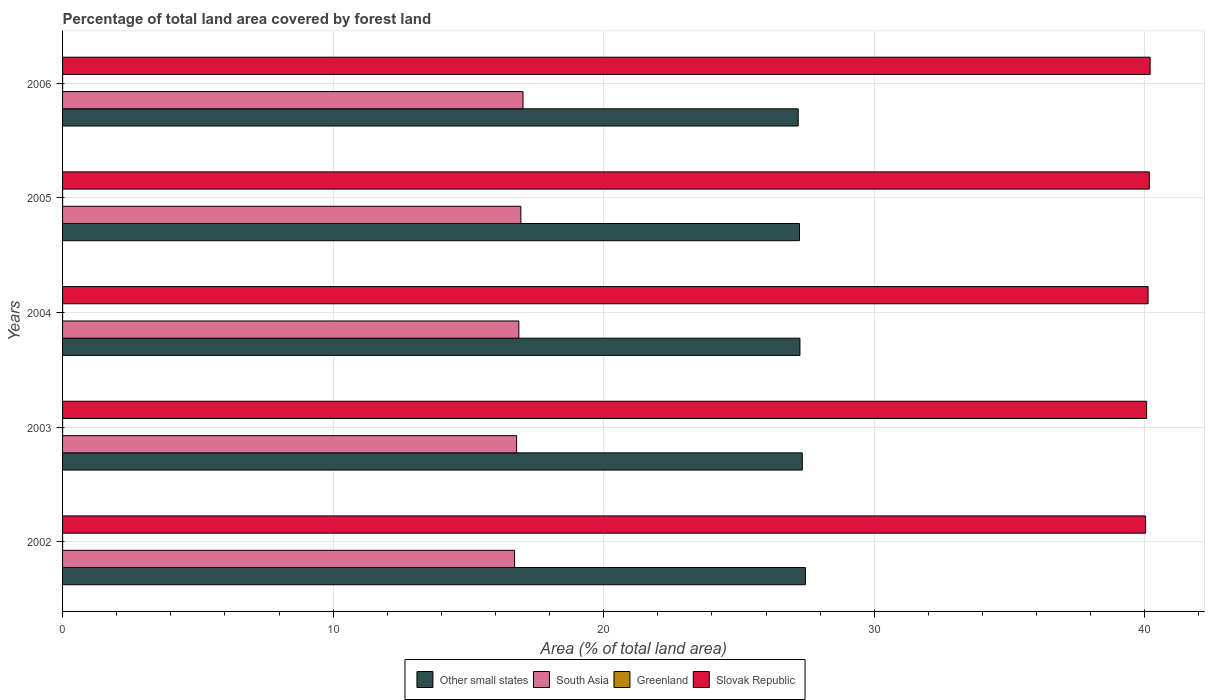How many different coloured bars are there?
Keep it short and to the point. 4. How many groups of bars are there?
Your answer should be compact. 5. Are the number of bars on each tick of the Y-axis equal?
Ensure brevity in your answer.  Yes. How many bars are there on the 1st tick from the top?
Offer a terse response. 4. How many bars are there on the 1st tick from the bottom?
Your answer should be compact. 4. What is the percentage of forest land in Slovak Republic in 2005?
Make the answer very short. 40.17. Across all years, what is the maximum percentage of forest land in South Asia?
Provide a succinct answer. 17.02. Across all years, what is the minimum percentage of forest land in Slovak Republic?
Keep it short and to the point. 40.03. What is the total percentage of forest land in South Asia in the graph?
Your response must be concise. 84.31. What is the difference between the percentage of forest land in Other small states in 2004 and that in 2006?
Your answer should be very brief. 0.06. What is the difference between the percentage of forest land in South Asia in 2004 and the percentage of forest land in Slovak Republic in 2002?
Offer a very short reply. -23.17. What is the average percentage of forest land in Greenland per year?
Your answer should be very brief. 0. In the year 2006, what is the difference between the percentage of forest land in Slovak Republic and percentage of forest land in Other small states?
Make the answer very short. 13.01. In how many years, is the percentage of forest land in South Asia greater than 38 %?
Ensure brevity in your answer.  0. What is the ratio of the percentage of forest land in Slovak Republic in 2002 to that in 2003?
Your response must be concise. 1. Is the percentage of forest land in Other small states in 2005 less than that in 2006?
Your response must be concise. No. Is the difference between the percentage of forest land in Slovak Republic in 2004 and 2006 greater than the difference between the percentage of forest land in Other small states in 2004 and 2006?
Provide a short and direct response. No. What is the difference between the highest and the second highest percentage of forest land in Other small states?
Offer a terse response. 0.11. What is the difference between the highest and the lowest percentage of forest land in Other small states?
Provide a short and direct response. 0.27. In how many years, is the percentage of forest land in Other small states greater than the average percentage of forest land in Other small states taken over all years?
Keep it short and to the point. 2. Is the sum of the percentage of forest land in South Asia in 2002 and 2006 greater than the maximum percentage of forest land in Other small states across all years?
Provide a short and direct response. Yes. What does the 2nd bar from the top in 2002 represents?
Provide a succinct answer. Greenland. What does the 4th bar from the bottom in 2004 represents?
Offer a terse response. Slovak Republic. Are all the bars in the graph horizontal?
Ensure brevity in your answer.  Yes. What is the difference between two consecutive major ticks on the X-axis?
Your answer should be compact. 10. Are the values on the major ticks of X-axis written in scientific E-notation?
Keep it short and to the point. No. Where does the legend appear in the graph?
Offer a terse response. Bottom center. What is the title of the graph?
Give a very brief answer. Percentage of total land area covered by forest land. What is the label or title of the X-axis?
Your answer should be very brief. Area (% of total land area). What is the label or title of the Y-axis?
Your response must be concise. Years. What is the Area (% of total land area) of Other small states in 2002?
Give a very brief answer. 27.45. What is the Area (% of total land area) of South Asia in 2002?
Offer a terse response. 16.71. What is the Area (% of total land area) in Greenland in 2002?
Offer a terse response. 0. What is the Area (% of total land area) in Slovak Republic in 2002?
Keep it short and to the point. 40.03. What is the Area (% of total land area) of Other small states in 2003?
Offer a terse response. 27.34. What is the Area (% of total land area) in South Asia in 2003?
Make the answer very short. 16.78. What is the Area (% of total land area) in Greenland in 2003?
Keep it short and to the point. 0. What is the Area (% of total land area) of Slovak Republic in 2003?
Your answer should be very brief. 40.07. What is the Area (% of total land area) in Other small states in 2004?
Give a very brief answer. 27.25. What is the Area (% of total land area) of South Asia in 2004?
Provide a short and direct response. 16.86. What is the Area (% of total land area) in Greenland in 2004?
Provide a succinct answer. 0. What is the Area (% of total land area) in Slovak Republic in 2004?
Provide a succinct answer. 40.12. What is the Area (% of total land area) in Other small states in 2005?
Give a very brief answer. 27.24. What is the Area (% of total land area) in South Asia in 2005?
Your answer should be very brief. 16.94. What is the Area (% of total land area) in Greenland in 2005?
Your answer should be very brief. 0. What is the Area (% of total land area) in Slovak Republic in 2005?
Offer a very short reply. 40.17. What is the Area (% of total land area) of Other small states in 2006?
Ensure brevity in your answer.  27.19. What is the Area (% of total land area) in South Asia in 2006?
Your answer should be very brief. 17.02. What is the Area (% of total land area) of Greenland in 2006?
Your answer should be very brief. 0. What is the Area (% of total land area) of Slovak Republic in 2006?
Offer a very short reply. 40.2. Across all years, what is the maximum Area (% of total land area) of Other small states?
Your response must be concise. 27.45. Across all years, what is the maximum Area (% of total land area) of South Asia?
Keep it short and to the point. 17.02. Across all years, what is the maximum Area (% of total land area) of Greenland?
Keep it short and to the point. 0. Across all years, what is the maximum Area (% of total land area) in Slovak Republic?
Offer a terse response. 40.2. Across all years, what is the minimum Area (% of total land area) in Other small states?
Make the answer very short. 27.19. Across all years, what is the minimum Area (% of total land area) of South Asia?
Your answer should be very brief. 16.71. Across all years, what is the minimum Area (% of total land area) of Greenland?
Your answer should be compact. 0. Across all years, what is the minimum Area (% of total land area) of Slovak Republic?
Provide a short and direct response. 40.03. What is the total Area (% of total land area) in Other small states in the graph?
Ensure brevity in your answer.  136.47. What is the total Area (% of total land area) in South Asia in the graph?
Ensure brevity in your answer.  84.31. What is the total Area (% of total land area) in Greenland in the graph?
Provide a short and direct response. 0. What is the total Area (% of total land area) of Slovak Republic in the graph?
Ensure brevity in your answer.  200.58. What is the difference between the Area (% of total land area) of Other small states in 2002 and that in 2003?
Offer a very short reply. 0.11. What is the difference between the Area (% of total land area) in South Asia in 2002 and that in 2003?
Keep it short and to the point. -0.08. What is the difference between the Area (% of total land area) of Greenland in 2002 and that in 2003?
Offer a very short reply. 0. What is the difference between the Area (% of total land area) of Slovak Republic in 2002 and that in 2003?
Make the answer very short. -0.04. What is the difference between the Area (% of total land area) of Other small states in 2002 and that in 2004?
Provide a short and direct response. 0.2. What is the difference between the Area (% of total land area) of South Asia in 2002 and that in 2004?
Provide a succinct answer. -0.16. What is the difference between the Area (% of total land area) of Greenland in 2002 and that in 2004?
Offer a very short reply. 0. What is the difference between the Area (% of total land area) of Slovak Republic in 2002 and that in 2004?
Ensure brevity in your answer.  -0.09. What is the difference between the Area (% of total land area) in Other small states in 2002 and that in 2005?
Keep it short and to the point. 0.22. What is the difference between the Area (% of total land area) of South Asia in 2002 and that in 2005?
Offer a very short reply. -0.23. What is the difference between the Area (% of total land area) in Slovak Republic in 2002 and that in 2005?
Your response must be concise. -0.14. What is the difference between the Area (% of total land area) in Other small states in 2002 and that in 2006?
Offer a very short reply. 0.27. What is the difference between the Area (% of total land area) in South Asia in 2002 and that in 2006?
Give a very brief answer. -0.31. What is the difference between the Area (% of total land area) in Greenland in 2002 and that in 2006?
Your response must be concise. 0. What is the difference between the Area (% of total land area) of Slovak Republic in 2002 and that in 2006?
Keep it short and to the point. -0.17. What is the difference between the Area (% of total land area) of Other small states in 2003 and that in 2004?
Your answer should be compact. 0.09. What is the difference between the Area (% of total land area) of South Asia in 2003 and that in 2004?
Offer a terse response. -0.08. What is the difference between the Area (% of total land area) in Slovak Republic in 2003 and that in 2004?
Provide a short and direct response. -0.05. What is the difference between the Area (% of total land area) of Other small states in 2003 and that in 2005?
Offer a very short reply. 0.11. What is the difference between the Area (% of total land area) in South Asia in 2003 and that in 2005?
Offer a very short reply. -0.16. What is the difference between the Area (% of total land area) in Greenland in 2003 and that in 2005?
Make the answer very short. 0. What is the difference between the Area (% of total land area) of Slovak Republic in 2003 and that in 2005?
Your answer should be very brief. -0.1. What is the difference between the Area (% of total land area) in Other small states in 2003 and that in 2006?
Ensure brevity in your answer.  0.15. What is the difference between the Area (% of total land area) of South Asia in 2003 and that in 2006?
Keep it short and to the point. -0.24. What is the difference between the Area (% of total land area) in Greenland in 2003 and that in 2006?
Your answer should be very brief. 0. What is the difference between the Area (% of total land area) of Slovak Republic in 2003 and that in 2006?
Your response must be concise. -0.13. What is the difference between the Area (% of total land area) of Other small states in 2004 and that in 2005?
Your answer should be compact. 0.02. What is the difference between the Area (% of total land area) in South Asia in 2004 and that in 2005?
Keep it short and to the point. -0.08. What is the difference between the Area (% of total land area) in Greenland in 2004 and that in 2005?
Keep it short and to the point. 0. What is the difference between the Area (% of total land area) of Slovak Republic in 2004 and that in 2005?
Keep it short and to the point. -0.05. What is the difference between the Area (% of total land area) in Other small states in 2004 and that in 2006?
Give a very brief answer. 0.06. What is the difference between the Area (% of total land area) of South Asia in 2004 and that in 2006?
Your response must be concise. -0.15. What is the difference between the Area (% of total land area) of Greenland in 2004 and that in 2006?
Your response must be concise. 0. What is the difference between the Area (% of total land area) of Slovak Republic in 2004 and that in 2006?
Ensure brevity in your answer.  -0.07. What is the difference between the Area (% of total land area) of Other small states in 2005 and that in 2006?
Provide a succinct answer. 0.05. What is the difference between the Area (% of total land area) in South Asia in 2005 and that in 2006?
Give a very brief answer. -0.08. What is the difference between the Area (% of total land area) in Greenland in 2005 and that in 2006?
Give a very brief answer. 0. What is the difference between the Area (% of total land area) in Slovak Republic in 2005 and that in 2006?
Ensure brevity in your answer.  -0.03. What is the difference between the Area (% of total land area) in Other small states in 2002 and the Area (% of total land area) in South Asia in 2003?
Offer a very short reply. 10.67. What is the difference between the Area (% of total land area) of Other small states in 2002 and the Area (% of total land area) of Greenland in 2003?
Keep it short and to the point. 27.45. What is the difference between the Area (% of total land area) of Other small states in 2002 and the Area (% of total land area) of Slovak Republic in 2003?
Offer a terse response. -12.61. What is the difference between the Area (% of total land area) in South Asia in 2002 and the Area (% of total land area) in Greenland in 2003?
Your answer should be very brief. 16.71. What is the difference between the Area (% of total land area) in South Asia in 2002 and the Area (% of total land area) in Slovak Republic in 2003?
Ensure brevity in your answer.  -23.36. What is the difference between the Area (% of total land area) of Greenland in 2002 and the Area (% of total land area) of Slovak Republic in 2003?
Your answer should be very brief. -40.07. What is the difference between the Area (% of total land area) in Other small states in 2002 and the Area (% of total land area) in South Asia in 2004?
Offer a very short reply. 10.59. What is the difference between the Area (% of total land area) of Other small states in 2002 and the Area (% of total land area) of Greenland in 2004?
Ensure brevity in your answer.  27.45. What is the difference between the Area (% of total land area) of Other small states in 2002 and the Area (% of total land area) of Slovak Republic in 2004?
Keep it short and to the point. -12.67. What is the difference between the Area (% of total land area) in South Asia in 2002 and the Area (% of total land area) in Greenland in 2004?
Ensure brevity in your answer.  16.71. What is the difference between the Area (% of total land area) in South Asia in 2002 and the Area (% of total land area) in Slovak Republic in 2004?
Make the answer very short. -23.41. What is the difference between the Area (% of total land area) in Greenland in 2002 and the Area (% of total land area) in Slovak Republic in 2004?
Keep it short and to the point. -40.12. What is the difference between the Area (% of total land area) in Other small states in 2002 and the Area (% of total land area) in South Asia in 2005?
Provide a short and direct response. 10.52. What is the difference between the Area (% of total land area) in Other small states in 2002 and the Area (% of total land area) in Greenland in 2005?
Give a very brief answer. 27.45. What is the difference between the Area (% of total land area) of Other small states in 2002 and the Area (% of total land area) of Slovak Republic in 2005?
Keep it short and to the point. -12.71. What is the difference between the Area (% of total land area) in South Asia in 2002 and the Area (% of total land area) in Greenland in 2005?
Ensure brevity in your answer.  16.71. What is the difference between the Area (% of total land area) in South Asia in 2002 and the Area (% of total land area) in Slovak Republic in 2005?
Make the answer very short. -23.46. What is the difference between the Area (% of total land area) of Greenland in 2002 and the Area (% of total land area) of Slovak Republic in 2005?
Provide a succinct answer. -40.17. What is the difference between the Area (% of total land area) of Other small states in 2002 and the Area (% of total land area) of South Asia in 2006?
Your response must be concise. 10.44. What is the difference between the Area (% of total land area) in Other small states in 2002 and the Area (% of total land area) in Greenland in 2006?
Your answer should be compact. 27.45. What is the difference between the Area (% of total land area) of Other small states in 2002 and the Area (% of total land area) of Slovak Republic in 2006?
Your answer should be compact. -12.74. What is the difference between the Area (% of total land area) in South Asia in 2002 and the Area (% of total land area) in Greenland in 2006?
Provide a short and direct response. 16.71. What is the difference between the Area (% of total land area) in South Asia in 2002 and the Area (% of total land area) in Slovak Republic in 2006?
Provide a short and direct response. -23.49. What is the difference between the Area (% of total land area) in Greenland in 2002 and the Area (% of total land area) in Slovak Republic in 2006?
Your answer should be very brief. -40.19. What is the difference between the Area (% of total land area) of Other small states in 2003 and the Area (% of total land area) of South Asia in 2004?
Give a very brief answer. 10.48. What is the difference between the Area (% of total land area) in Other small states in 2003 and the Area (% of total land area) in Greenland in 2004?
Ensure brevity in your answer.  27.34. What is the difference between the Area (% of total land area) in Other small states in 2003 and the Area (% of total land area) in Slovak Republic in 2004?
Your response must be concise. -12.78. What is the difference between the Area (% of total land area) of South Asia in 2003 and the Area (% of total land area) of Greenland in 2004?
Ensure brevity in your answer.  16.78. What is the difference between the Area (% of total land area) in South Asia in 2003 and the Area (% of total land area) in Slovak Republic in 2004?
Offer a terse response. -23.34. What is the difference between the Area (% of total land area) in Greenland in 2003 and the Area (% of total land area) in Slovak Republic in 2004?
Your answer should be compact. -40.12. What is the difference between the Area (% of total land area) of Other small states in 2003 and the Area (% of total land area) of South Asia in 2005?
Offer a terse response. 10.4. What is the difference between the Area (% of total land area) of Other small states in 2003 and the Area (% of total land area) of Greenland in 2005?
Provide a short and direct response. 27.34. What is the difference between the Area (% of total land area) of Other small states in 2003 and the Area (% of total land area) of Slovak Republic in 2005?
Provide a short and direct response. -12.82. What is the difference between the Area (% of total land area) of South Asia in 2003 and the Area (% of total land area) of Greenland in 2005?
Offer a terse response. 16.78. What is the difference between the Area (% of total land area) in South Asia in 2003 and the Area (% of total land area) in Slovak Republic in 2005?
Provide a short and direct response. -23.38. What is the difference between the Area (% of total land area) in Greenland in 2003 and the Area (% of total land area) in Slovak Republic in 2005?
Provide a short and direct response. -40.17. What is the difference between the Area (% of total land area) of Other small states in 2003 and the Area (% of total land area) of South Asia in 2006?
Give a very brief answer. 10.32. What is the difference between the Area (% of total land area) in Other small states in 2003 and the Area (% of total land area) in Greenland in 2006?
Your answer should be very brief. 27.34. What is the difference between the Area (% of total land area) in Other small states in 2003 and the Area (% of total land area) in Slovak Republic in 2006?
Offer a very short reply. -12.85. What is the difference between the Area (% of total land area) of South Asia in 2003 and the Area (% of total land area) of Greenland in 2006?
Ensure brevity in your answer.  16.78. What is the difference between the Area (% of total land area) of South Asia in 2003 and the Area (% of total land area) of Slovak Republic in 2006?
Ensure brevity in your answer.  -23.41. What is the difference between the Area (% of total land area) in Greenland in 2003 and the Area (% of total land area) in Slovak Republic in 2006?
Ensure brevity in your answer.  -40.19. What is the difference between the Area (% of total land area) of Other small states in 2004 and the Area (% of total land area) of South Asia in 2005?
Ensure brevity in your answer.  10.31. What is the difference between the Area (% of total land area) in Other small states in 2004 and the Area (% of total land area) in Greenland in 2005?
Give a very brief answer. 27.25. What is the difference between the Area (% of total land area) in Other small states in 2004 and the Area (% of total land area) in Slovak Republic in 2005?
Keep it short and to the point. -12.91. What is the difference between the Area (% of total land area) of South Asia in 2004 and the Area (% of total land area) of Greenland in 2005?
Your answer should be compact. 16.86. What is the difference between the Area (% of total land area) in South Asia in 2004 and the Area (% of total land area) in Slovak Republic in 2005?
Your answer should be compact. -23.3. What is the difference between the Area (% of total land area) in Greenland in 2004 and the Area (% of total land area) in Slovak Republic in 2005?
Ensure brevity in your answer.  -40.17. What is the difference between the Area (% of total land area) in Other small states in 2004 and the Area (% of total land area) in South Asia in 2006?
Keep it short and to the point. 10.23. What is the difference between the Area (% of total land area) of Other small states in 2004 and the Area (% of total land area) of Greenland in 2006?
Your response must be concise. 27.25. What is the difference between the Area (% of total land area) of Other small states in 2004 and the Area (% of total land area) of Slovak Republic in 2006?
Make the answer very short. -12.94. What is the difference between the Area (% of total land area) of South Asia in 2004 and the Area (% of total land area) of Greenland in 2006?
Your answer should be compact. 16.86. What is the difference between the Area (% of total land area) in South Asia in 2004 and the Area (% of total land area) in Slovak Republic in 2006?
Ensure brevity in your answer.  -23.33. What is the difference between the Area (% of total land area) of Greenland in 2004 and the Area (% of total land area) of Slovak Republic in 2006?
Provide a short and direct response. -40.19. What is the difference between the Area (% of total land area) in Other small states in 2005 and the Area (% of total land area) in South Asia in 2006?
Offer a terse response. 10.22. What is the difference between the Area (% of total land area) in Other small states in 2005 and the Area (% of total land area) in Greenland in 2006?
Provide a short and direct response. 27.23. What is the difference between the Area (% of total land area) in Other small states in 2005 and the Area (% of total land area) in Slovak Republic in 2006?
Your answer should be compact. -12.96. What is the difference between the Area (% of total land area) of South Asia in 2005 and the Area (% of total land area) of Greenland in 2006?
Your answer should be very brief. 16.94. What is the difference between the Area (% of total land area) of South Asia in 2005 and the Area (% of total land area) of Slovak Republic in 2006?
Your answer should be very brief. -23.26. What is the difference between the Area (% of total land area) of Greenland in 2005 and the Area (% of total land area) of Slovak Republic in 2006?
Ensure brevity in your answer.  -40.19. What is the average Area (% of total land area) of Other small states per year?
Give a very brief answer. 27.29. What is the average Area (% of total land area) of South Asia per year?
Provide a succinct answer. 16.86. What is the average Area (% of total land area) of Slovak Republic per year?
Your response must be concise. 40.12. In the year 2002, what is the difference between the Area (% of total land area) in Other small states and Area (% of total land area) in South Asia?
Keep it short and to the point. 10.75. In the year 2002, what is the difference between the Area (% of total land area) in Other small states and Area (% of total land area) in Greenland?
Provide a short and direct response. 27.45. In the year 2002, what is the difference between the Area (% of total land area) of Other small states and Area (% of total land area) of Slovak Republic?
Provide a succinct answer. -12.57. In the year 2002, what is the difference between the Area (% of total land area) in South Asia and Area (% of total land area) in Greenland?
Your response must be concise. 16.71. In the year 2002, what is the difference between the Area (% of total land area) of South Asia and Area (% of total land area) of Slovak Republic?
Your answer should be compact. -23.32. In the year 2002, what is the difference between the Area (% of total land area) of Greenland and Area (% of total land area) of Slovak Republic?
Keep it short and to the point. -40.03. In the year 2003, what is the difference between the Area (% of total land area) in Other small states and Area (% of total land area) in South Asia?
Keep it short and to the point. 10.56. In the year 2003, what is the difference between the Area (% of total land area) of Other small states and Area (% of total land area) of Greenland?
Keep it short and to the point. 27.34. In the year 2003, what is the difference between the Area (% of total land area) of Other small states and Area (% of total land area) of Slovak Republic?
Give a very brief answer. -12.72. In the year 2003, what is the difference between the Area (% of total land area) of South Asia and Area (% of total land area) of Greenland?
Your answer should be compact. 16.78. In the year 2003, what is the difference between the Area (% of total land area) of South Asia and Area (% of total land area) of Slovak Republic?
Offer a terse response. -23.28. In the year 2003, what is the difference between the Area (% of total land area) of Greenland and Area (% of total land area) of Slovak Republic?
Make the answer very short. -40.07. In the year 2004, what is the difference between the Area (% of total land area) of Other small states and Area (% of total land area) of South Asia?
Ensure brevity in your answer.  10.39. In the year 2004, what is the difference between the Area (% of total land area) in Other small states and Area (% of total land area) in Greenland?
Offer a very short reply. 27.25. In the year 2004, what is the difference between the Area (% of total land area) of Other small states and Area (% of total land area) of Slovak Republic?
Provide a short and direct response. -12.87. In the year 2004, what is the difference between the Area (% of total land area) of South Asia and Area (% of total land area) of Greenland?
Your answer should be compact. 16.86. In the year 2004, what is the difference between the Area (% of total land area) of South Asia and Area (% of total land area) of Slovak Republic?
Offer a terse response. -23.26. In the year 2004, what is the difference between the Area (% of total land area) in Greenland and Area (% of total land area) in Slovak Republic?
Your answer should be very brief. -40.12. In the year 2005, what is the difference between the Area (% of total land area) of Other small states and Area (% of total land area) of South Asia?
Provide a succinct answer. 10.3. In the year 2005, what is the difference between the Area (% of total land area) of Other small states and Area (% of total land area) of Greenland?
Offer a very short reply. 27.23. In the year 2005, what is the difference between the Area (% of total land area) in Other small states and Area (% of total land area) in Slovak Republic?
Make the answer very short. -12.93. In the year 2005, what is the difference between the Area (% of total land area) in South Asia and Area (% of total land area) in Greenland?
Ensure brevity in your answer.  16.94. In the year 2005, what is the difference between the Area (% of total land area) of South Asia and Area (% of total land area) of Slovak Republic?
Your answer should be very brief. -23.23. In the year 2005, what is the difference between the Area (% of total land area) of Greenland and Area (% of total land area) of Slovak Republic?
Provide a short and direct response. -40.17. In the year 2006, what is the difference between the Area (% of total land area) in Other small states and Area (% of total land area) in South Asia?
Make the answer very short. 10.17. In the year 2006, what is the difference between the Area (% of total land area) in Other small states and Area (% of total land area) in Greenland?
Offer a very short reply. 27.19. In the year 2006, what is the difference between the Area (% of total land area) of Other small states and Area (% of total land area) of Slovak Republic?
Your answer should be very brief. -13.01. In the year 2006, what is the difference between the Area (% of total land area) of South Asia and Area (% of total land area) of Greenland?
Keep it short and to the point. 17.02. In the year 2006, what is the difference between the Area (% of total land area) of South Asia and Area (% of total land area) of Slovak Republic?
Give a very brief answer. -23.18. In the year 2006, what is the difference between the Area (% of total land area) in Greenland and Area (% of total land area) in Slovak Republic?
Your response must be concise. -40.19. What is the ratio of the Area (% of total land area) of Greenland in 2002 to that in 2003?
Keep it short and to the point. 1. What is the ratio of the Area (% of total land area) of Other small states in 2002 to that in 2004?
Your response must be concise. 1.01. What is the ratio of the Area (% of total land area) of South Asia in 2002 to that in 2005?
Ensure brevity in your answer.  0.99. What is the ratio of the Area (% of total land area) in Slovak Republic in 2002 to that in 2005?
Offer a very short reply. 1. What is the ratio of the Area (% of total land area) of Other small states in 2002 to that in 2006?
Keep it short and to the point. 1.01. What is the ratio of the Area (% of total land area) of South Asia in 2002 to that in 2006?
Your answer should be compact. 0.98. What is the ratio of the Area (% of total land area) in Greenland in 2002 to that in 2006?
Your response must be concise. 1. What is the ratio of the Area (% of total land area) in South Asia in 2003 to that in 2004?
Ensure brevity in your answer.  1. What is the ratio of the Area (% of total land area) in South Asia in 2003 to that in 2005?
Your response must be concise. 0.99. What is the ratio of the Area (% of total land area) in Other small states in 2003 to that in 2006?
Ensure brevity in your answer.  1.01. What is the ratio of the Area (% of total land area) in South Asia in 2003 to that in 2006?
Your answer should be compact. 0.99. What is the ratio of the Area (% of total land area) of Greenland in 2003 to that in 2006?
Ensure brevity in your answer.  1. What is the ratio of the Area (% of total land area) in South Asia in 2004 to that in 2005?
Offer a terse response. 1. What is the ratio of the Area (% of total land area) of Greenland in 2004 to that in 2005?
Provide a short and direct response. 1. What is the ratio of the Area (% of total land area) of Other small states in 2004 to that in 2006?
Your response must be concise. 1. What is the ratio of the Area (% of total land area) of South Asia in 2004 to that in 2006?
Give a very brief answer. 0.99. What is the ratio of the Area (% of total land area) of Greenland in 2004 to that in 2006?
Provide a succinct answer. 1. What is the ratio of the Area (% of total land area) of Slovak Republic in 2004 to that in 2006?
Your answer should be compact. 1. What is the ratio of the Area (% of total land area) in South Asia in 2005 to that in 2006?
Your answer should be compact. 1. What is the difference between the highest and the second highest Area (% of total land area) of Other small states?
Offer a very short reply. 0.11. What is the difference between the highest and the second highest Area (% of total land area) in South Asia?
Make the answer very short. 0.08. What is the difference between the highest and the second highest Area (% of total land area) in Greenland?
Give a very brief answer. 0. What is the difference between the highest and the second highest Area (% of total land area) in Slovak Republic?
Ensure brevity in your answer.  0.03. What is the difference between the highest and the lowest Area (% of total land area) of Other small states?
Your response must be concise. 0.27. What is the difference between the highest and the lowest Area (% of total land area) of South Asia?
Provide a short and direct response. 0.31. What is the difference between the highest and the lowest Area (% of total land area) in Greenland?
Your answer should be very brief. 0. What is the difference between the highest and the lowest Area (% of total land area) in Slovak Republic?
Keep it short and to the point. 0.17. 